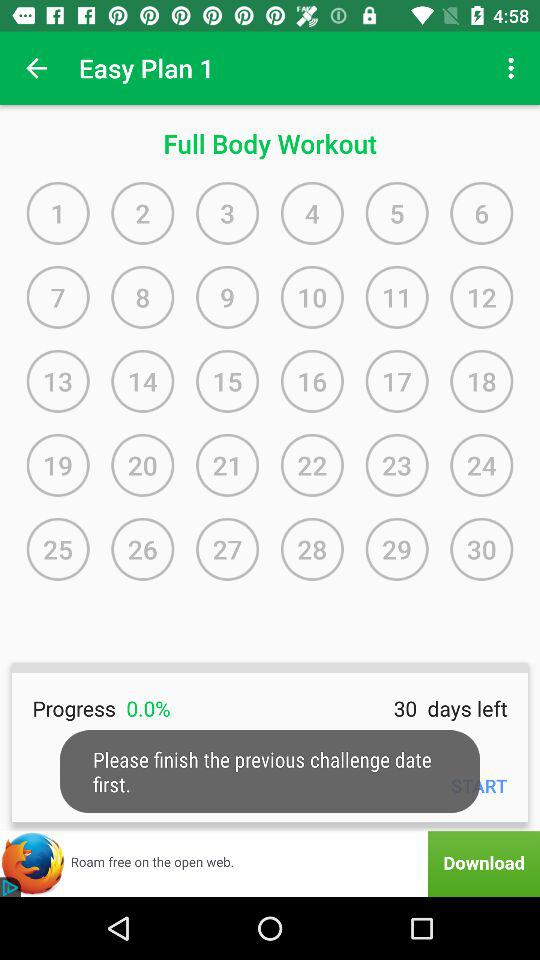What workout is this? This is a full body workout. 